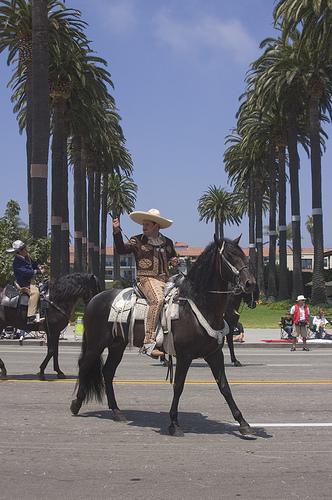Are the riders police?
Answer briefly. No. What is the man riding?
Write a very short answer. Horse. What kind of horses are these?
Write a very short answer. Brown. What is on the man's head?
Give a very brief answer. Sombrero. What is this man driving?
Short answer required. Horse. Is this in the city?
Concise answer only. Yes. What are these horses doing?
Keep it brief. Walking. Are there pine trees?
Be succinct. No. What animal is pictured?
Be succinct. Horse. Is this a paved road?
Quick response, please. Yes. Is there a man or woman on the horse in front of the others?
Quick response, please. Man. 